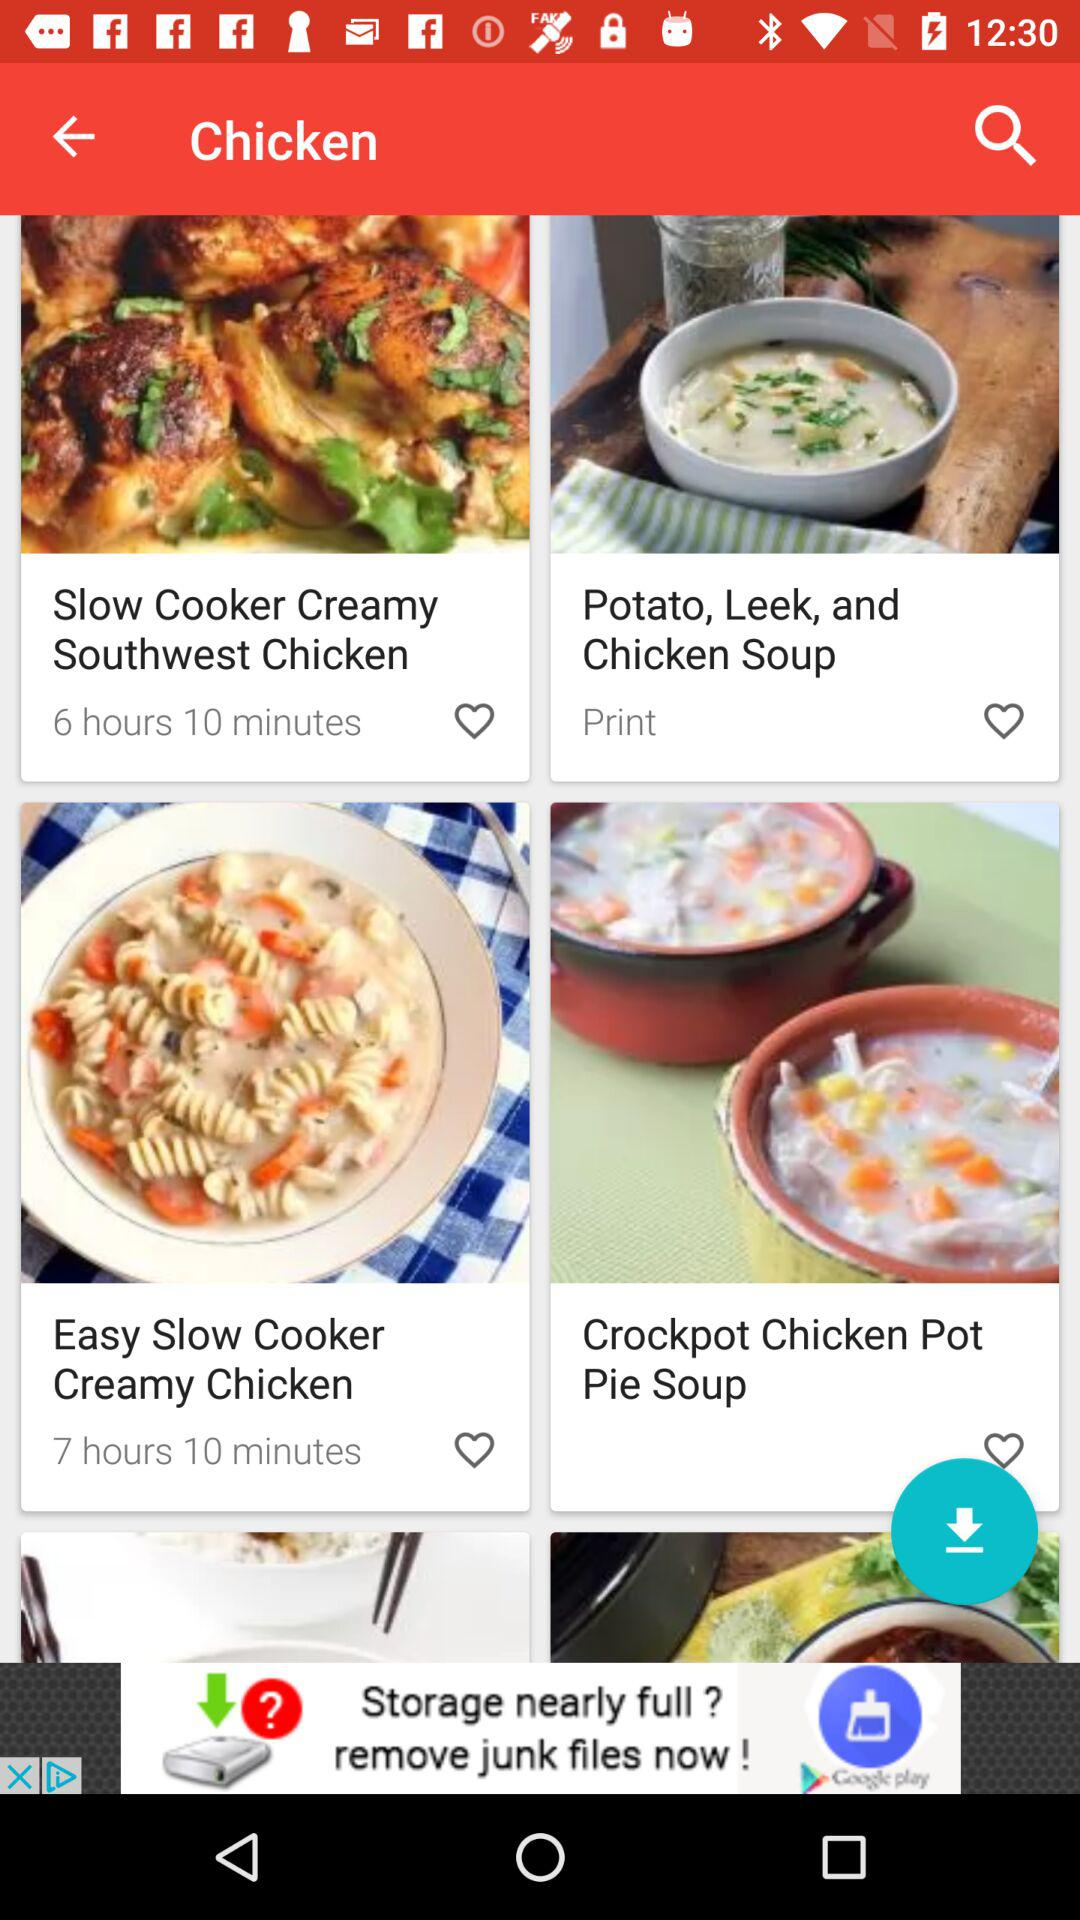How many recipes have an estimated cook time of more than 6 hours?
Answer the question using a single word or phrase. 2 